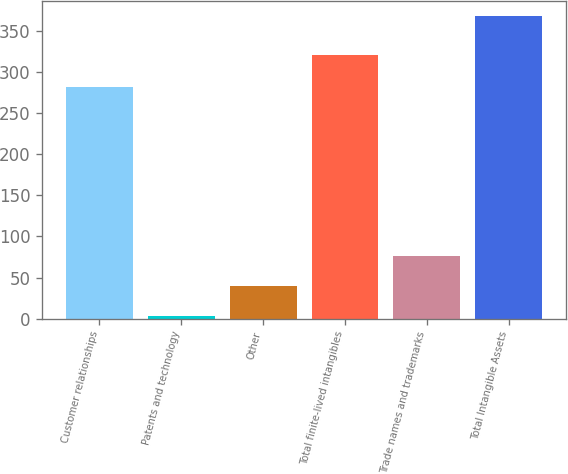Convert chart to OTSL. <chart><loc_0><loc_0><loc_500><loc_500><bar_chart><fcel>Customer relationships<fcel>Patents and technology<fcel>Other<fcel>Total finite-lived intangibles<fcel>Trade names and trademarks<fcel>Total Intangible Assets<nl><fcel>281.8<fcel>2.8<fcel>39.35<fcel>321.4<fcel>75.9<fcel>368.3<nl></chart> 